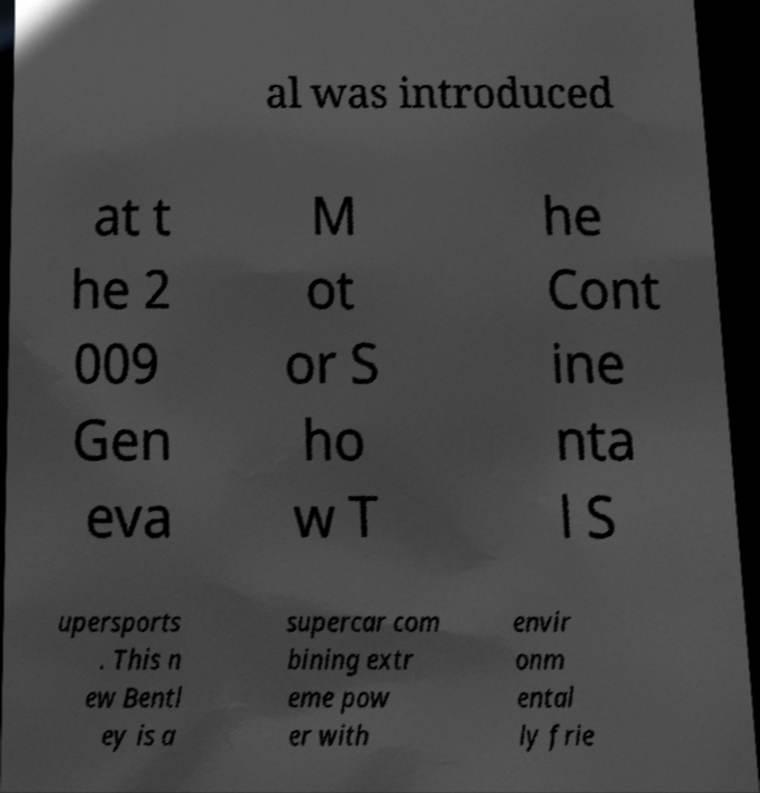Please identify and transcribe the text found in this image. al was introduced at t he 2 009 Gen eva M ot or S ho w T he Cont ine nta l S upersports . This n ew Bentl ey is a supercar com bining extr eme pow er with envir onm ental ly frie 